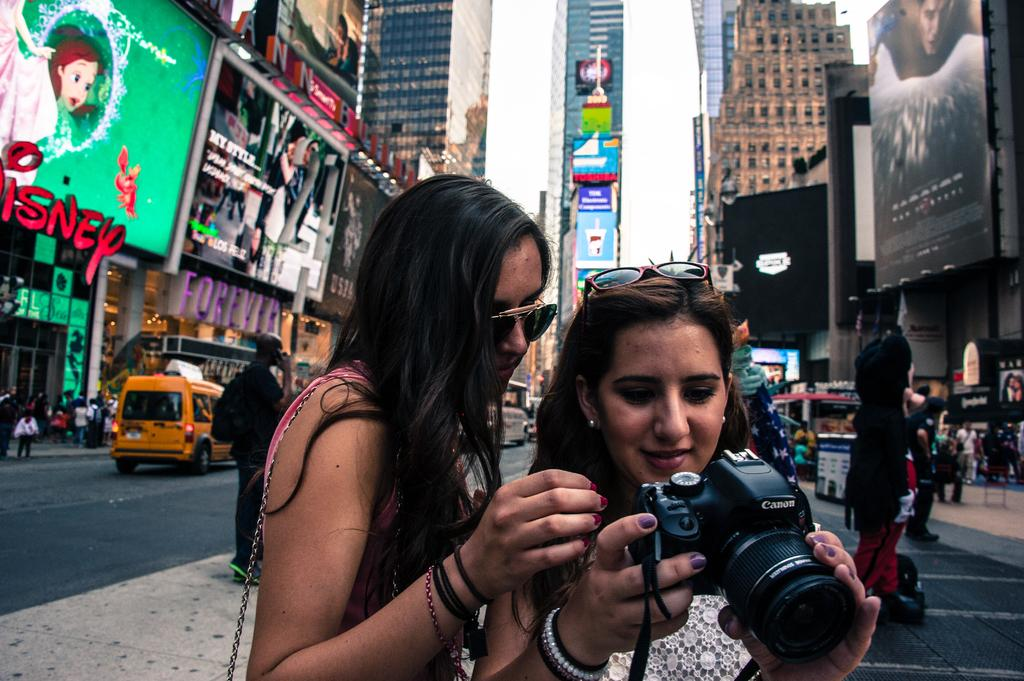<image>
Share a concise interpretation of the image provided. Two women in New York City look into a Canon brand camera. 